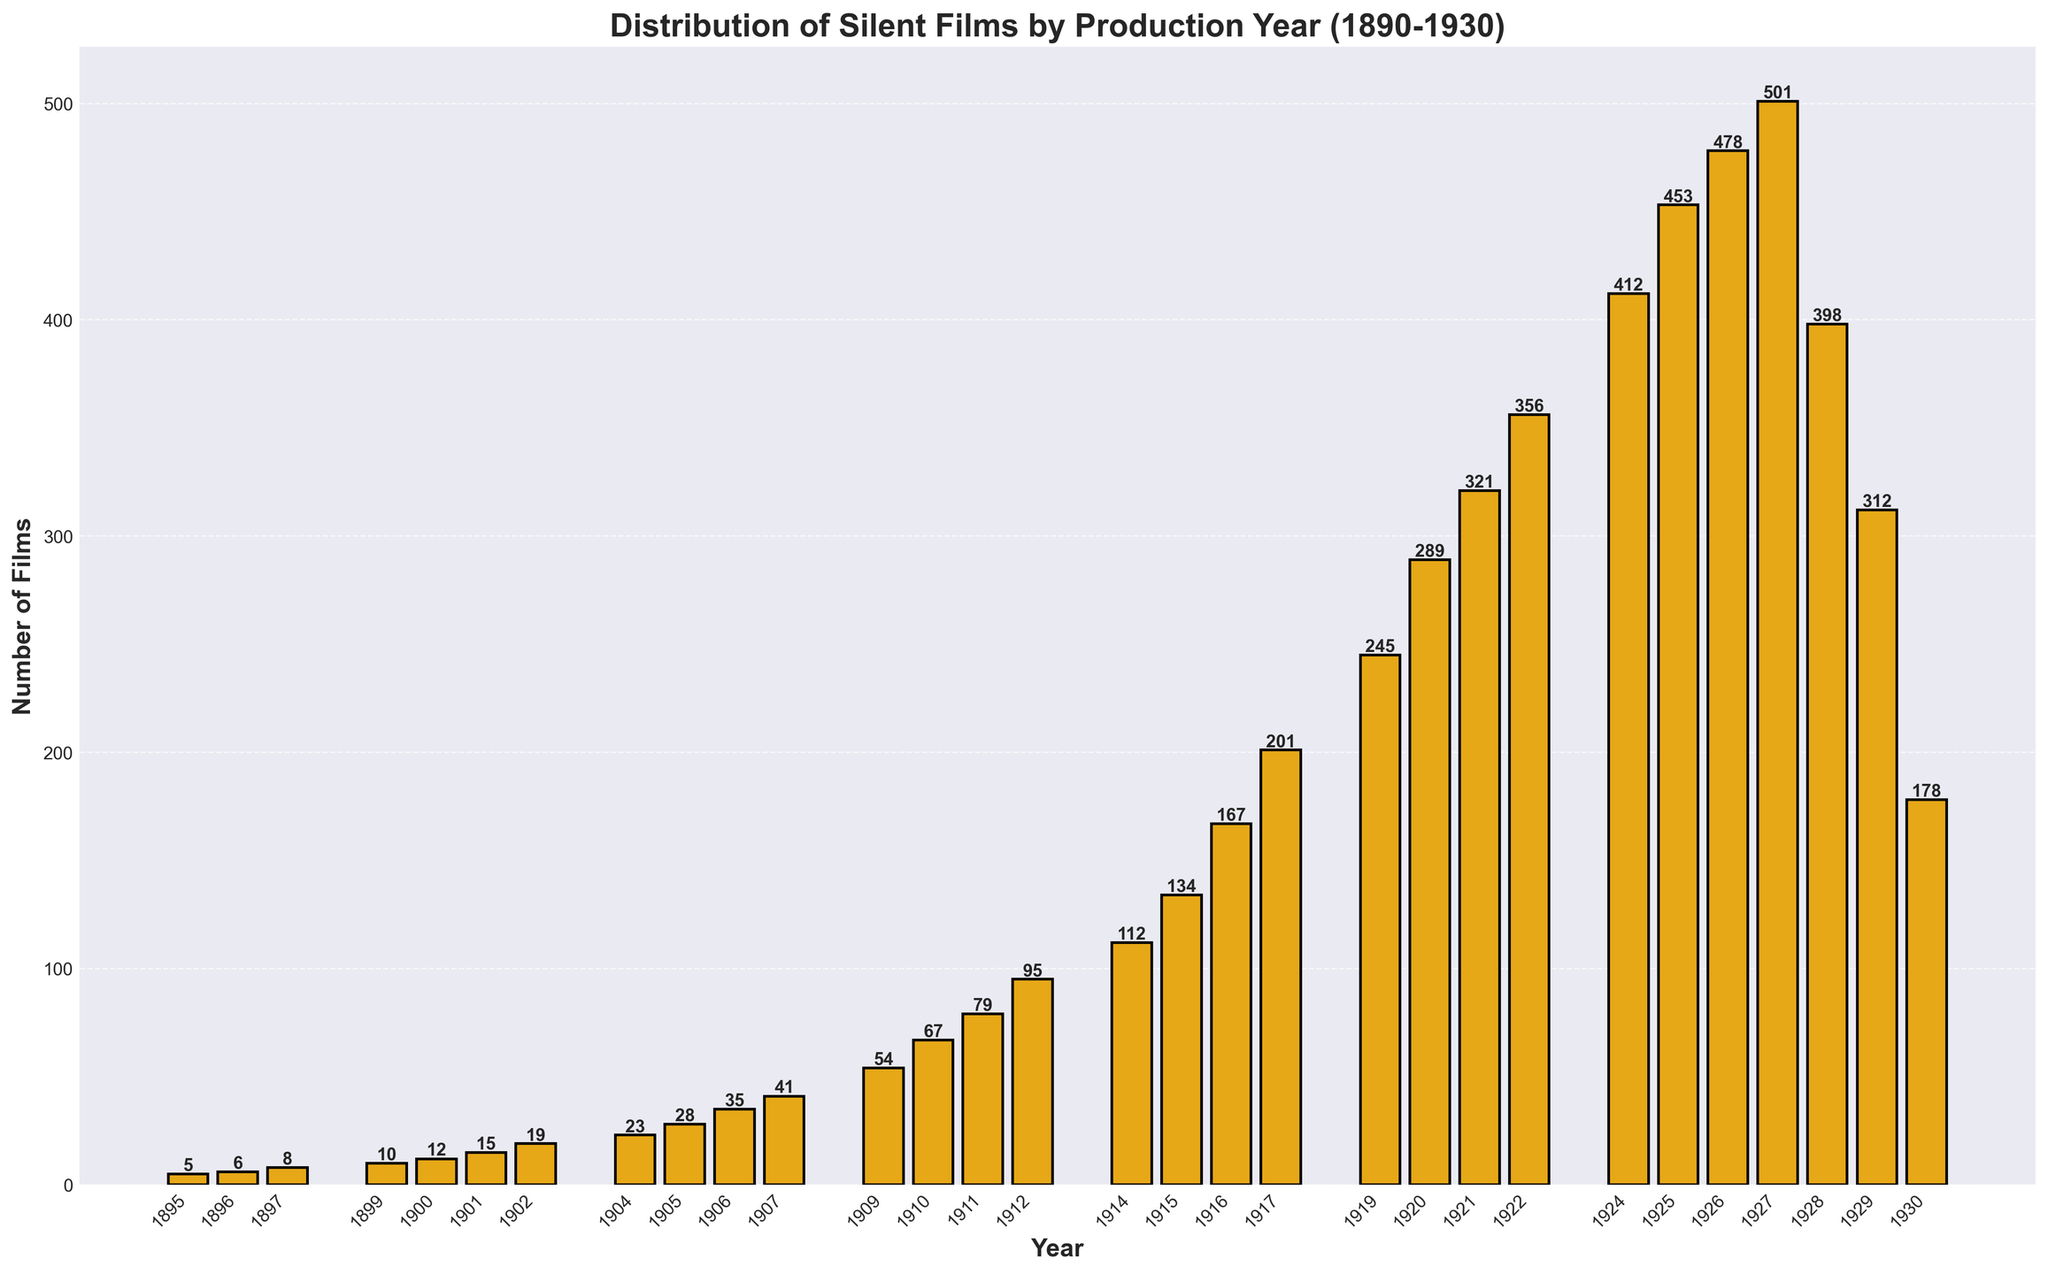what is the year with the highest number of silent films produced? The year with the highest bar indicates the maximum number of films produced. Observing the chart, 1927 has the tallest bar.
Answer: 1927 Which year saw the lowest production of silent films? The year with the shortest bar represents the lowest production. In the chart, 1895 has the shortest bar.
Answer: 1895 What is the total number of silent films produced between 1925 and 1930? Add the number of films produced in 1925, 1926, 1927, 1928, 1929, and 1930, which are 453, 478, 501, 398, 312, and 178 respectively. The sum is 2320.
Answer: 2320 How does the production in 1905 compare to that in 1910? Compare the height of the bars for 1905 and 1910. The bar for 1910 is taller, indicating more films were produced in 1910 (67) than in 1905 (28).
Answer: More in 1910 In what year did film production first exceed 100 films? Identify the year where the bar height first surpasses the 100-film mark. The year 1914 is the first instance with 112 films.
Answer: 1914 What is the average number of films produced per year from 1895 to 1930? Sum the number of films for each year and divide by the number of years. The total number of films is 5324, and there are 24 data points, so the average is 5324/24 ≈ 221.83.
Answer: ≈221.83 Which two adjacent years show the largest difference in the number of films produced? Calculate the difference between consecutive years and find the maximum difference. The largest difference is between 1926 (478) and 1927 (501 - 478 = 23), but the difference between 1927 (501) and 1928 (398) is larger (501 - 398 = 103). Hence, the largest difference is between 1927 and 1928.
Answer: 1927 and 1928 How many years produced more than 300 films? Count the number of bars exceeding the 300-film mark. The years 1920, 1922, 1924, 1925, 1926, 1927, 1928, and 1929 have more than 300 films.
Answer: 8 years 